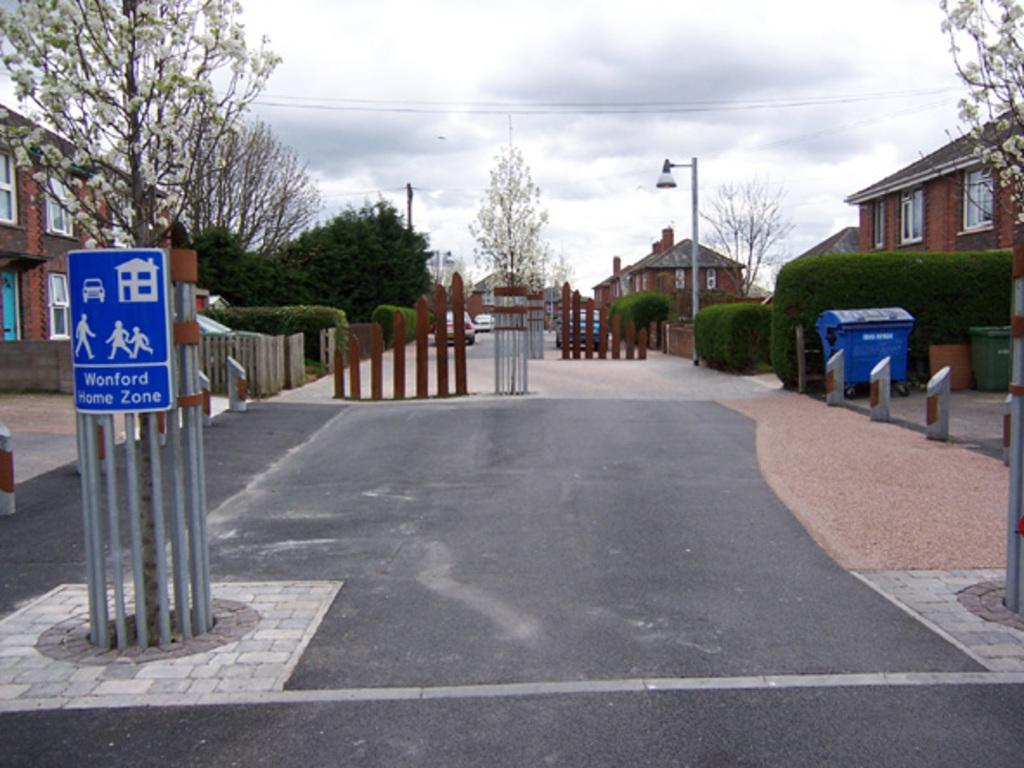<image>
Write a terse but informative summary of the picture. Wonford Home Zone is displayed on a sign by this crossing. 